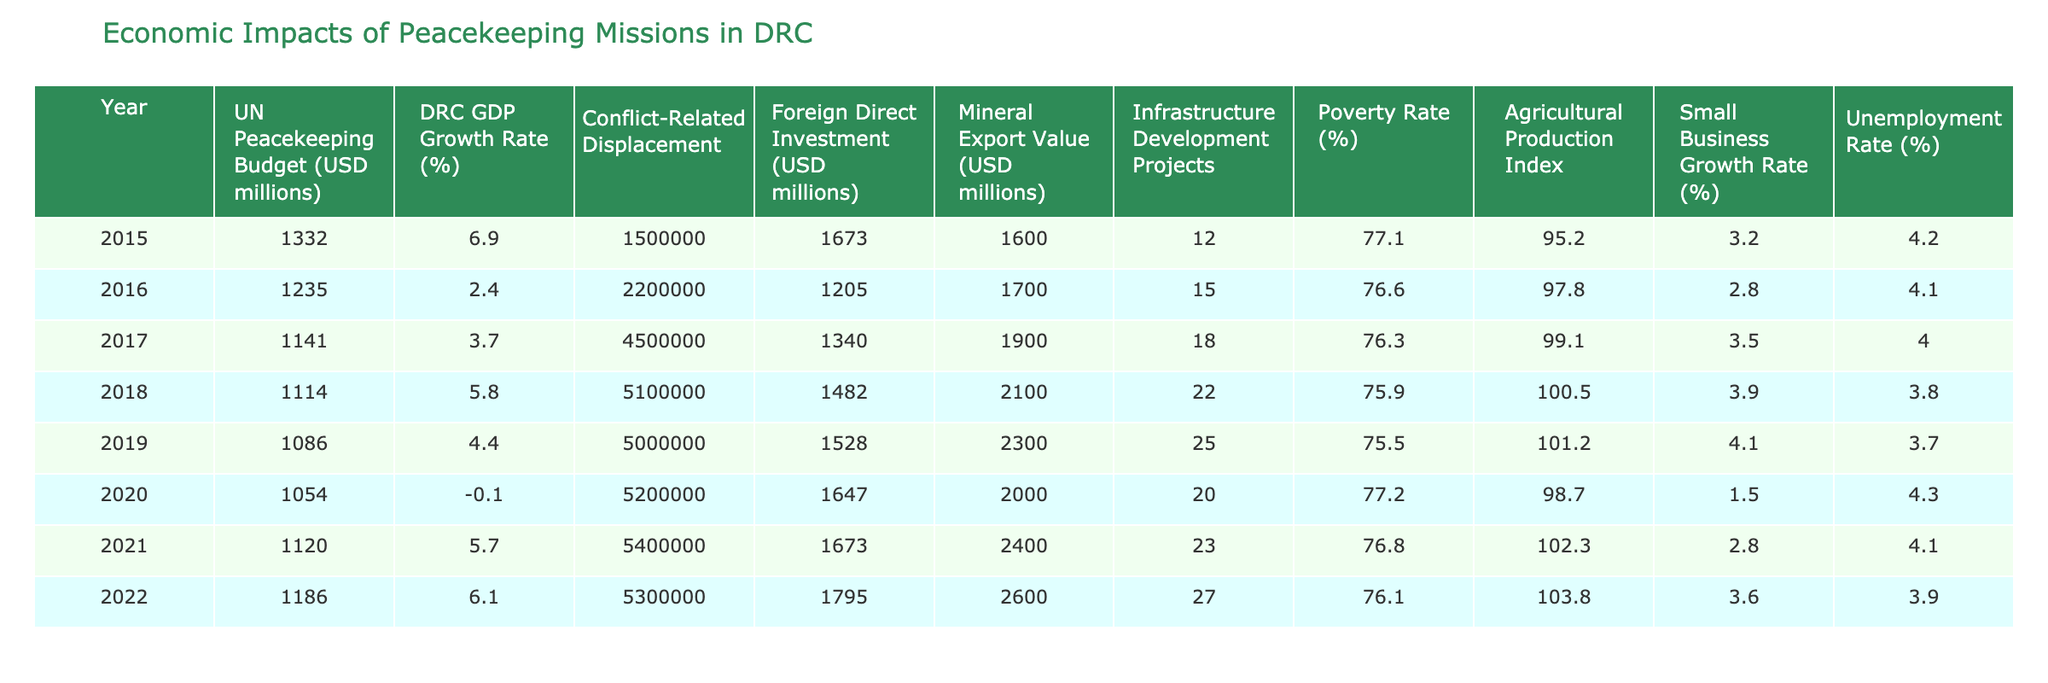What was the GDP growth rate in 2018? In the data for 2018, the GDP growth rate is specified as 5.8%.
Answer: 5.8% Which year had the highest foreign direct investment? By examining the foreign direct investment values, 2022 has the highest figure at 1795 million USD.
Answer: 2022 What was the total conflict-related displacement from 2015 to 2022? Adding the conflict-related displacement across the years from 2015 to 2022 gives: 1500000 + 2200000 + 4500000 + 5100000 + 5000000 + 5400000 + 5300000 = 30000000.
Answer: 30000000 Was the unemployment rate higher in 2017 or 2020? Comparing the unemployment rates, in 2017 it was 4.0% and in 2020 it was 4.3%, thus 2020 had a higher rate.
Answer: 2020 What is the average mineral export value for the years 2015 to 2022? The mineral export values are: 1600, 1700, 1900, 2100, 2300, 2400, 2600. Summing them gives 13900, then dividing by 7 gives an average of 1985.71 (rounded to 1986).
Answer: 1986 How many infrastructure development projects were there on average from 2015 to 2022? Summing the number of infrastructure development projects (12, 15, 18, 22, 25, 23, 27) gives 122, and dividing by 7 results in an average of approximately 17.43 (rounded to 17).
Answer: 17 Was there a year where the poverty rate dropped below 76%? The poverty rates for the years shown are all above 76%, with the lowest recorded at 75.5% in 2019. Thus, yes, there was a drop below 76%.
Answer: Yes Which year experienced the lowest GDP growth rate? The GDP growth rate was lowest in 2020 at -0.1%, evident from the data provided.
Answer: 2020 What was the difference in the foreign direct investment from 2016 to 2021? Calculating the difference: 1673 million (2021) - 1205 million (2016) equals 468 million USD increase in foreign direct investment.
Answer: 468 How did the small business growth rate trend from 2015 to 2022? Analyzing the small business growth rates (3.2, 2.8, 3.5, 3.9, 4.1, 2.8, 3.6), it shows variability with an overall trend of fluctuations rather than a clear increase or decrease.
Answer: Fluctuating 